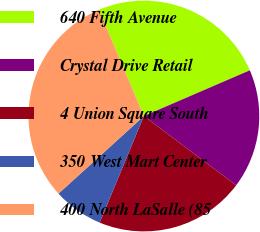<chart> <loc_0><loc_0><loc_500><loc_500><pie_chart><fcel>640 Fifth Avenue<fcel>Crystal Drive Retail<fcel>4 Union Square South<fcel>350 West Mart Center<fcel>400 North LaSalle (85<nl><fcel>24.9%<fcel>16.73%<fcel>21.01%<fcel>7.0%<fcel>30.35%<nl></chart> 